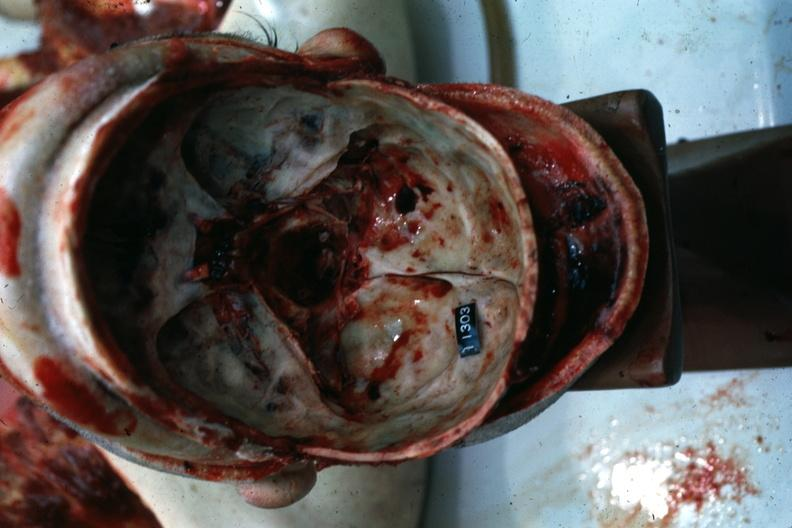s colon present?
Answer the question using a single word or phrase. No 